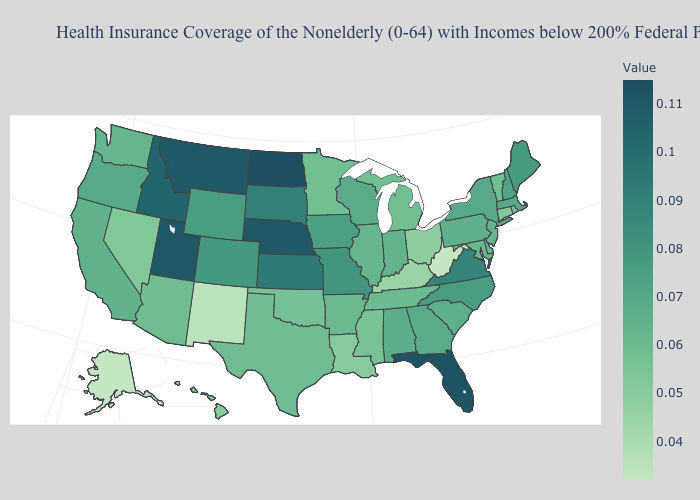Does the map have missing data?
Concise answer only. No. Is the legend a continuous bar?
Short answer required. Yes. Which states have the lowest value in the USA?
Write a very short answer. Alaska, West Virginia. 